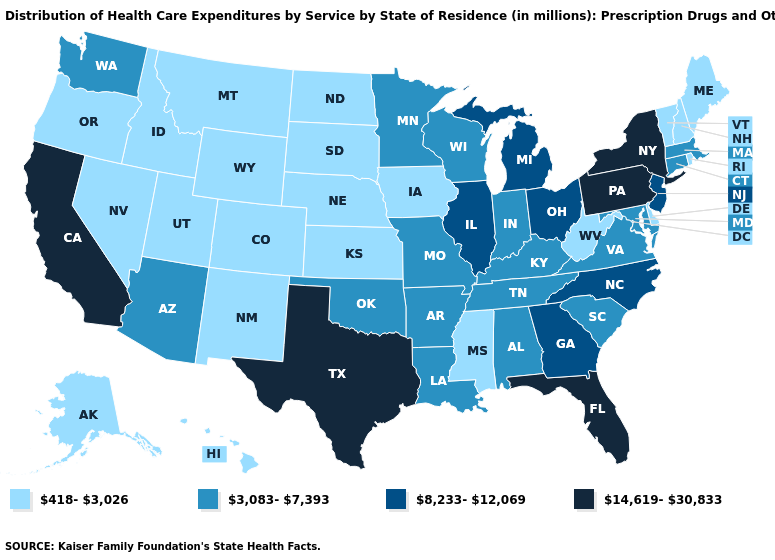What is the highest value in the South ?
Give a very brief answer. 14,619-30,833. Is the legend a continuous bar?
Concise answer only. No. Which states hav the highest value in the South?
Be succinct. Florida, Texas. Does Oregon have the same value as Maryland?
Answer briefly. No. Among the states that border Iowa , which have the highest value?
Keep it brief. Illinois. What is the lowest value in states that border Idaho?
Give a very brief answer. 418-3,026. What is the highest value in the USA?
Give a very brief answer. 14,619-30,833. Among the states that border Arizona , does California have the lowest value?
Give a very brief answer. No. Name the states that have a value in the range 14,619-30,833?
Answer briefly. California, Florida, New York, Pennsylvania, Texas. Is the legend a continuous bar?
Quick response, please. No. Does North Carolina have the same value as New Jersey?
Quick response, please. Yes. Name the states that have a value in the range 14,619-30,833?
Keep it brief. California, Florida, New York, Pennsylvania, Texas. Among the states that border Florida , does Georgia have the lowest value?
Concise answer only. No. Name the states that have a value in the range 418-3,026?
Keep it brief. Alaska, Colorado, Delaware, Hawaii, Idaho, Iowa, Kansas, Maine, Mississippi, Montana, Nebraska, Nevada, New Hampshire, New Mexico, North Dakota, Oregon, Rhode Island, South Dakota, Utah, Vermont, West Virginia, Wyoming. 